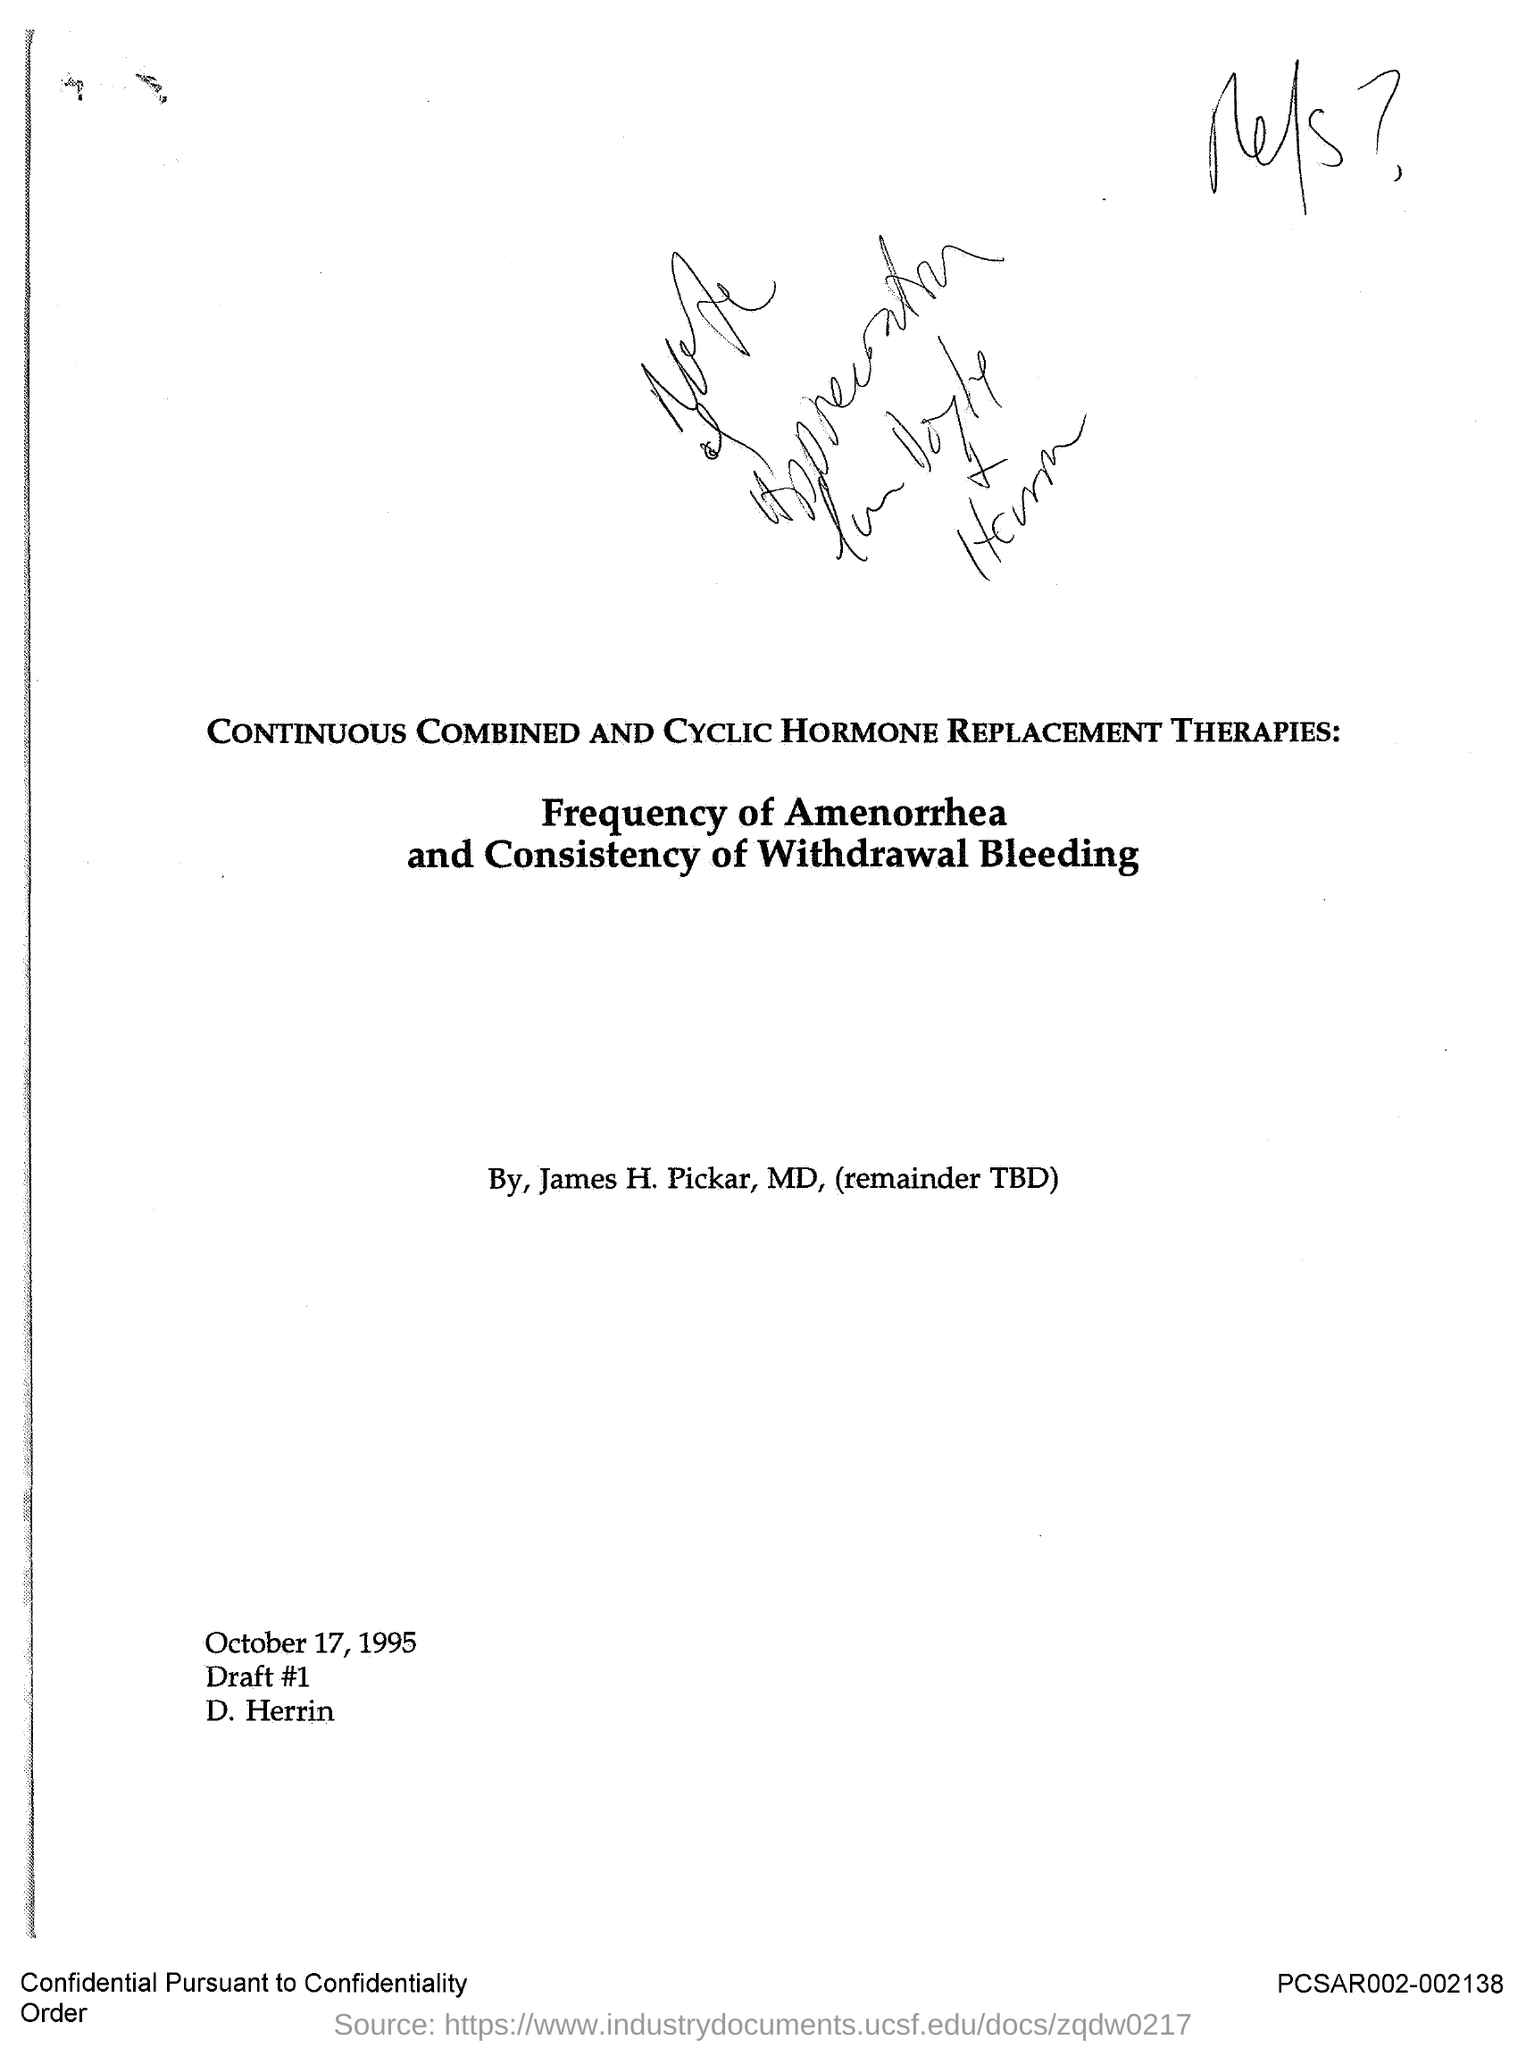Draw attention to some important aspects in this diagram. The date is October 17, 1995. I, D. Herrin, drafted it. What is the draft number?" is a question that seeks information about a specific topic. The sentence "1.." is not a complete question and does not provide sufficient information for a meaningful response. This article focuses on continuous combined and cyclic hormone replacement therapies. The author is James H. Pickar. 